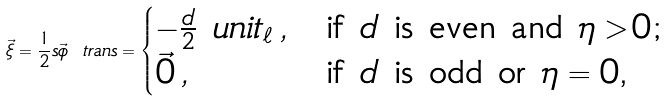Convert formula to latex. <formula><loc_0><loc_0><loc_500><loc_500>\vec { \xi } = \frac { 1 } { 2 } s \vec { \phi } \ t r a n s = \begin{cases} - \frac { d } { 2 } \ u n i t _ { \ell } \, , & \text {if $d$ is even and $\eta > 0$;} \\ \vec { 0 } \, , & \text {if $d$ is odd or $\eta = 0$,} \end{cases}</formula> 